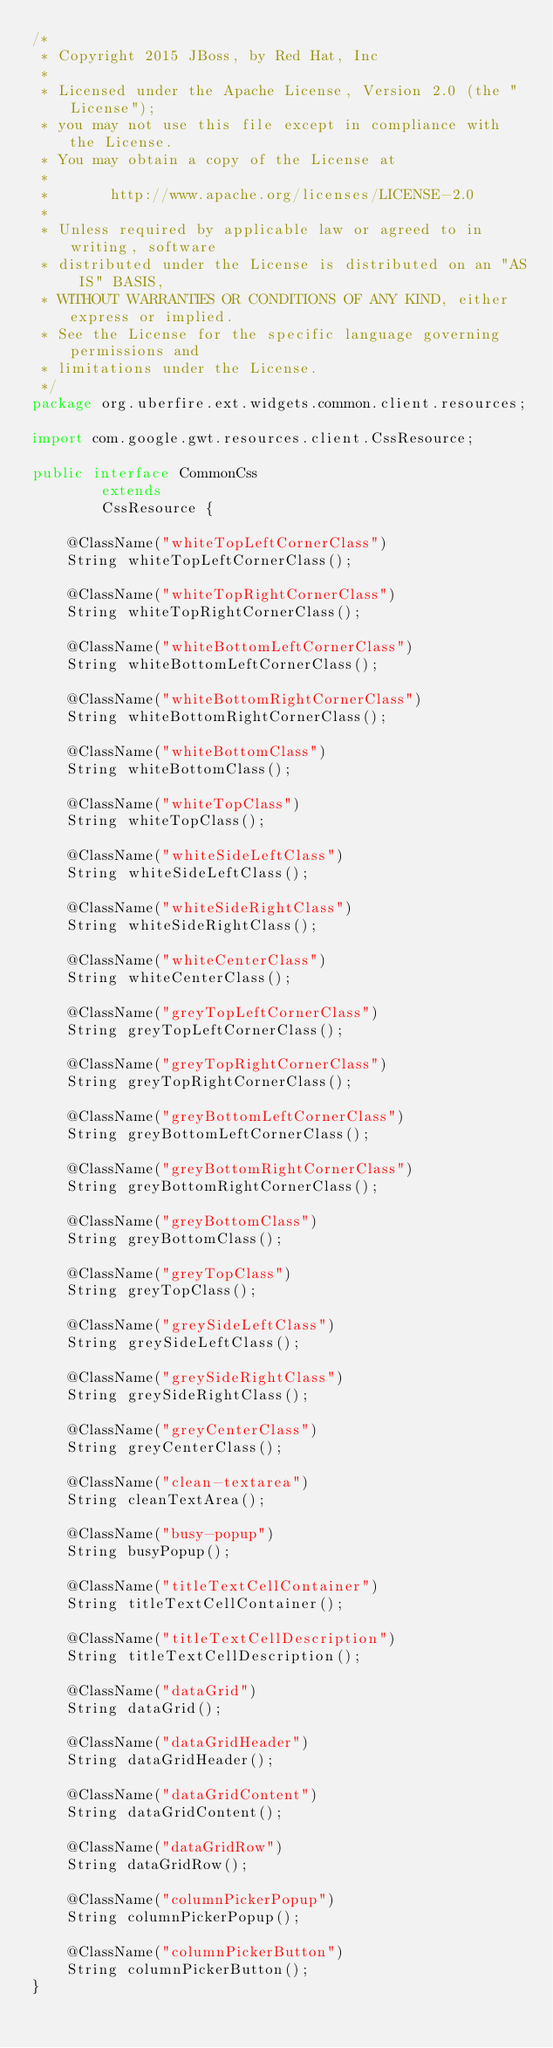Convert code to text. <code><loc_0><loc_0><loc_500><loc_500><_Java_>/*
 * Copyright 2015 JBoss, by Red Hat, Inc
 *
 * Licensed under the Apache License, Version 2.0 (the "License");
 * you may not use this file except in compliance with the License.
 * You may obtain a copy of the License at
 *
 *       http://www.apache.org/licenses/LICENSE-2.0
 *
 * Unless required by applicable law or agreed to in writing, software
 * distributed under the License is distributed on an "AS IS" BASIS,
 * WITHOUT WARRANTIES OR CONDITIONS OF ANY KIND, either express or implied.
 * See the License for the specific language governing permissions and
 * limitations under the License.
 */
package org.uberfire.ext.widgets.common.client.resources;

import com.google.gwt.resources.client.CssResource;

public interface CommonCss
        extends
        CssResource {

    @ClassName("whiteTopLeftCornerClass")
    String whiteTopLeftCornerClass();

    @ClassName("whiteTopRightCornerClass")
    String whiteTopRightCornerClass();

    @ClassName("whiteBottomLeftCornerClass")
    String whiteBottomLeftCornerClass();

    @ClassName("whiteBottomRightCornerClass")
    String whiteBottomRightCornerClass();

    @ClassName("whiteBottomClass")
    String whiteBottomClass();

    @ClassName("whiteTopClass")
    String whiteTopClass();

    @ClassName("whiteSideLeftClass")
    String whiteSideLeftClass();

    @ClassName("whiteSideRightClass")
    String whiteSideRightClass();

    @ClassName("whiteCenterClass")
    String whiteCenterClass();

    @ClassName("greyTopLeftCornerClass")
    String greyTopLeftCornerClass();

    @ClassName("greyTopRightCornerClass")
    String greyTopRightCornerClass();

    @ClassName("greyBottomLeftCornerClass")
    String greyBottomLeftCornerClass();

    @ClassName("greyBottomRightCornerClass")
    String greyBottomRightCornerClass();

    @ClassName("greyBottomClass")
    String greyBottomClass();

    @ClassName("greyTopClass")
    String greyTopClass();

    @ClassName("greySideLeftClass")
    String greySideLeftClass();

    @ClassName("greySideRightClass")
    String greySideRightClass();

    @ClassName("greyCenterClass")
    String greyCenterClass();

    @ClassName("clean-textarea")
    String cleanTextArea();

    @ClassName("busy-popup")
    String busyPopup();

    @ClassName("titleTextCellContainer")
    String titleTextCellContainer();

    @ClassName("titleTextCellDescription")
    String titleTextCellDescription();

    @ClassName("dataGrid")
    String dataGrid();

    @ClassName("dataGridHeader")
    String dataGridHeader();

    @ClassName("dataGridContent")
    String dataGridContent();

    @ClassName("dataGridRow")
    String dataGridRow();

    @ClassName("columnPickerPopup")
    String columnPickerPopup();

    @ClassName("columnPickerButton")
    String columnPickerButton();
}
</code> 